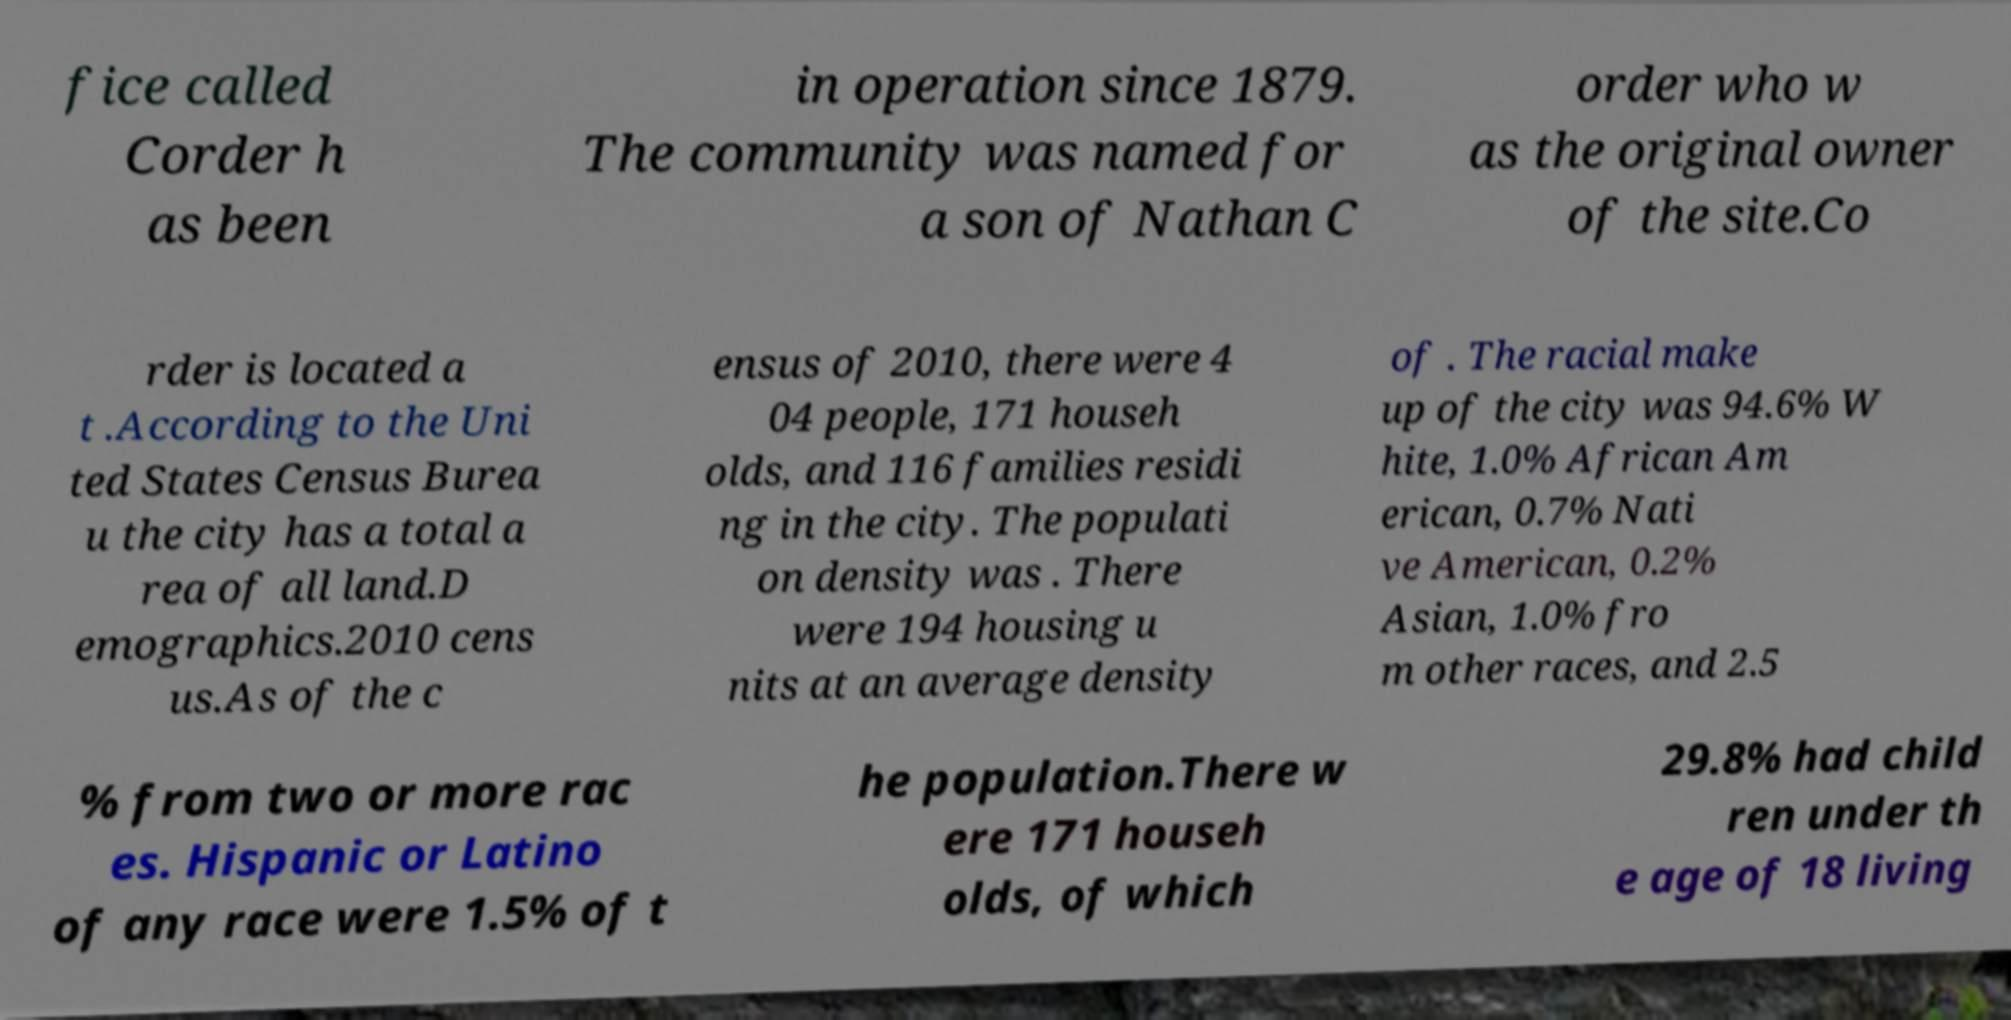For documentation purposes, I need the text within this image transcribed. Could you provide that? fice called Corder h as been in operation since 1879. The community was named for a son of Nathan C order who w as the original owner of the site.Co rder is located a t .According to the Uni ted States Census Burea u the city has a total a rea of all land.D emographics.2010 cens us.As of the c ensus of 2010, there were 4 04 people, 171 househ olds, and 116 families residi ng in the city. The populati on density was . There were 194 housing u nits at an average density of . The racial make up of the city was 94.6% W hite, 1.0% African Am erican, 0.7% Nati ve American, 0.2% Asian, 1.0% fro m other races, and 2.5 % from two or more rac es. Hispanic or Latino of any race were 1.5% of t he population.There w ere 171 househ olds, of which 29.8% had child ren under th e age of 18 living 